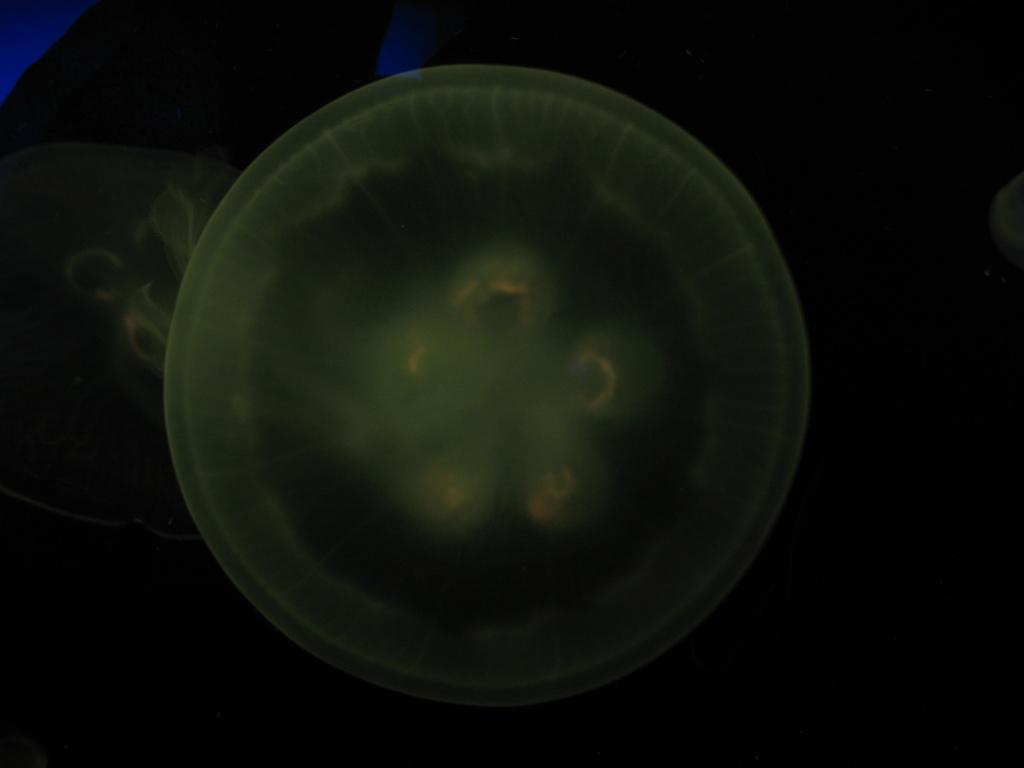What is the main subject of the image? There is a jellyfish in the image. What can be observed about the background of the image? The background of the image is dark. What type of cup is being used in the office system depicted in the image? There is no cup, office, or system present in the image; it features a jellyfish against a dark background. 